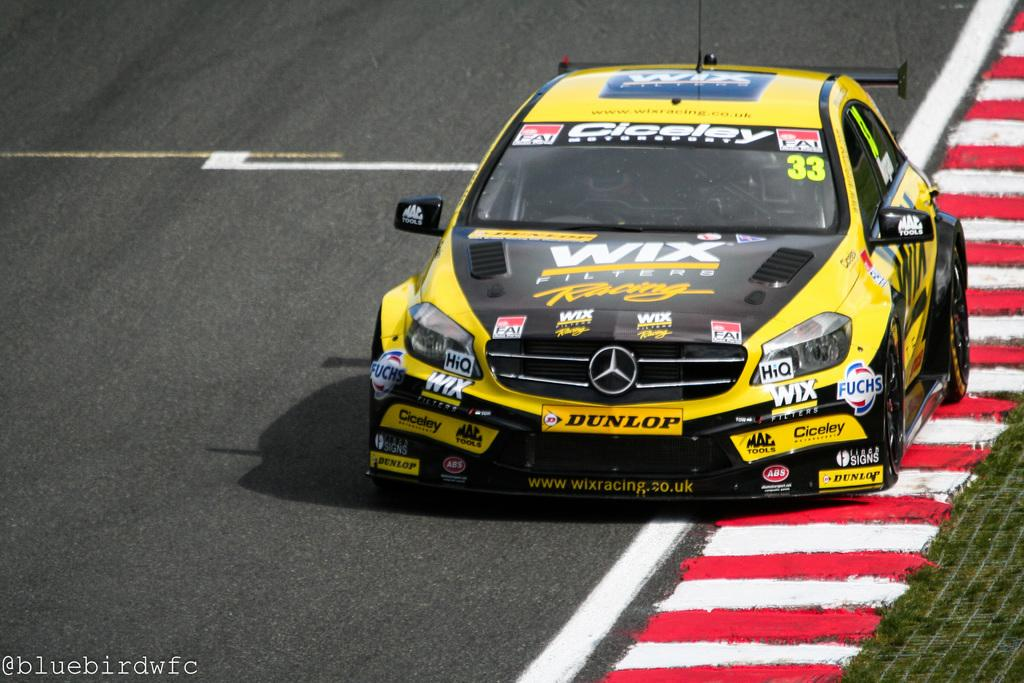What type of vehicle is in the image? There is a yellow color racing car in the image. Where is the racing car located? The racing car is on the road. What additional feature can be seen on the racing car? There is text on the racing car. Can you describe the text in the bottom left-hand corner of the image? There is text in the bottom left-hand corner of the image. Can you see the driver inside the racing car? There is no indication of a driver inside the racing car in the image. 